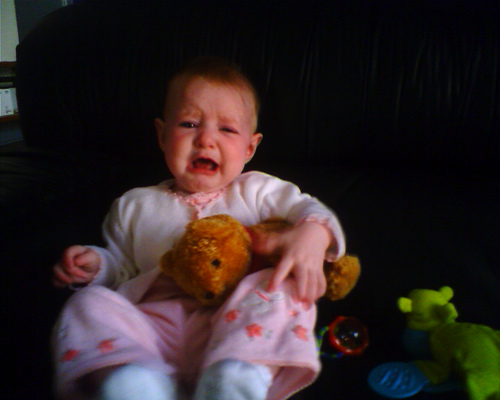What cartoon characters are on the high chair cover? There do not appear to be any cartoon characters on the high chair cover. The cover features a plain design without any visible patterns or images that indicate cartoon characters. 